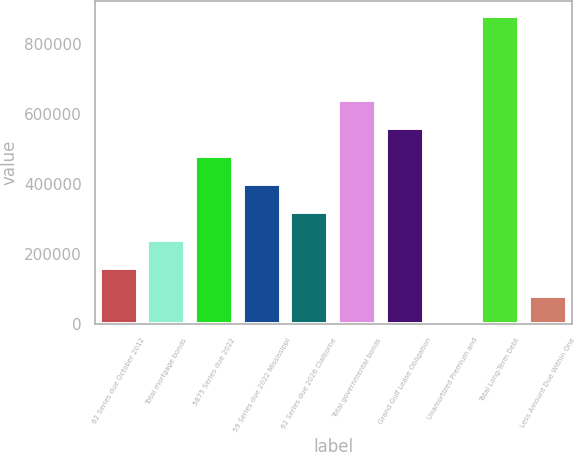Convert chart to OTSL. <chart><loc_0><loc_0><loc_500><loc_500><bar_chart><fcel>62 Series due October 2012<fcel>Total mortgage bonds<fcel>5875 Series due 2022<fcel>59 Series due 2022 Mississippi<fcel>62 Series due 2026 Claiborne<fcel>Total governmental bonds<fcel>Grand Gulf Lease Obligation<fcel>Unamortized Premium and<fcel>Total Long-Term Debt<fcel>Less Amount Due Within One<nl><fcel>160804<fcel>240699<fcel>480385<fcel>400490<fcel>320595<fcel>640176<fcel>560281<fcel>1013<fcel>879862<fcel>80908.4<nl></chart> 